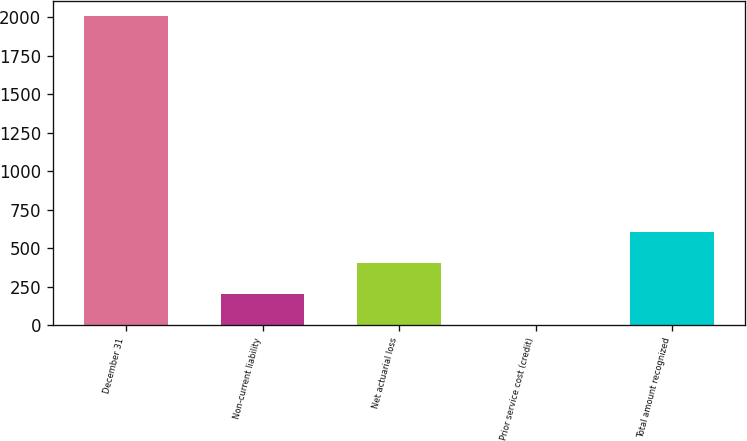<chart> <loc_0><loc_0><loc_500><loc_500><bar_chart><fcel>December 31<fcel>Non-current liability<fcel>Net actuarial loss<fcel>Prior service cost (credit)<fcel>Total amount recognized<nl><fcel>2007<fcel>200.88<fcel>401.56<fcel>0.2<fcel>602.24<nl></chart> 